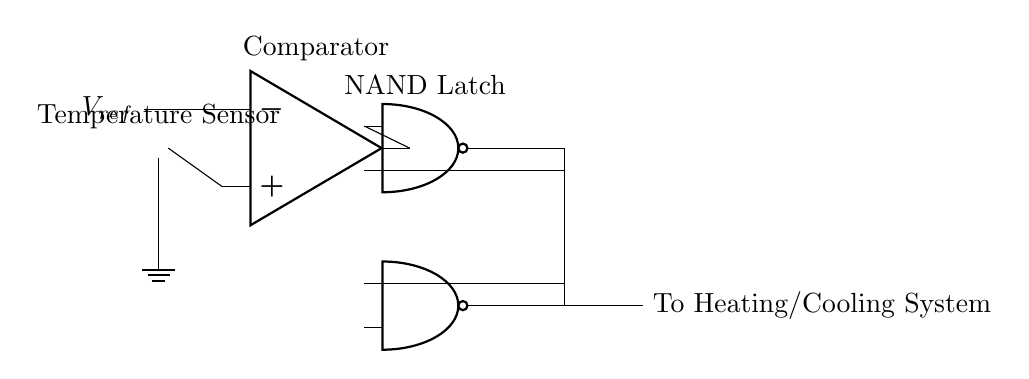What type of component is used as a temperature sensor? The temperature sensor in this circuit is a thermistor, as indicated by the label in the diagram.
Answer: thermistor What is the function of the comparator in this circuit? The comparator compares the temperature sensor output with a reference voltage and determines if the output should trigger the NAND gates based on the temperature being higher or lower than the set point.
Answer: comparison How many NAND gates are included in the circuit? There are two NAND gates present in the circuit, as shown by the two distinct NAND port symbols drawn in the diagram.
Answer: two What output does the NAND latch provide? The NAND latch provides an output signal that regulates the heating or cooling system based on the results from the comparator and the NAND logic.
Answer: regulation signal Explain how the output of the temperature sensor affects the NAND latch. The output from the temperature sensor is fed into the comparator, which evaluates it against the reference voltage. Depending on this comparison, the comparator's output will either enable or disable the NAND gates. If the conditions are met, the NAND latch will set its state accordingly, allowing the control signal to flow to the heating or cooling system.
Answer: output control 